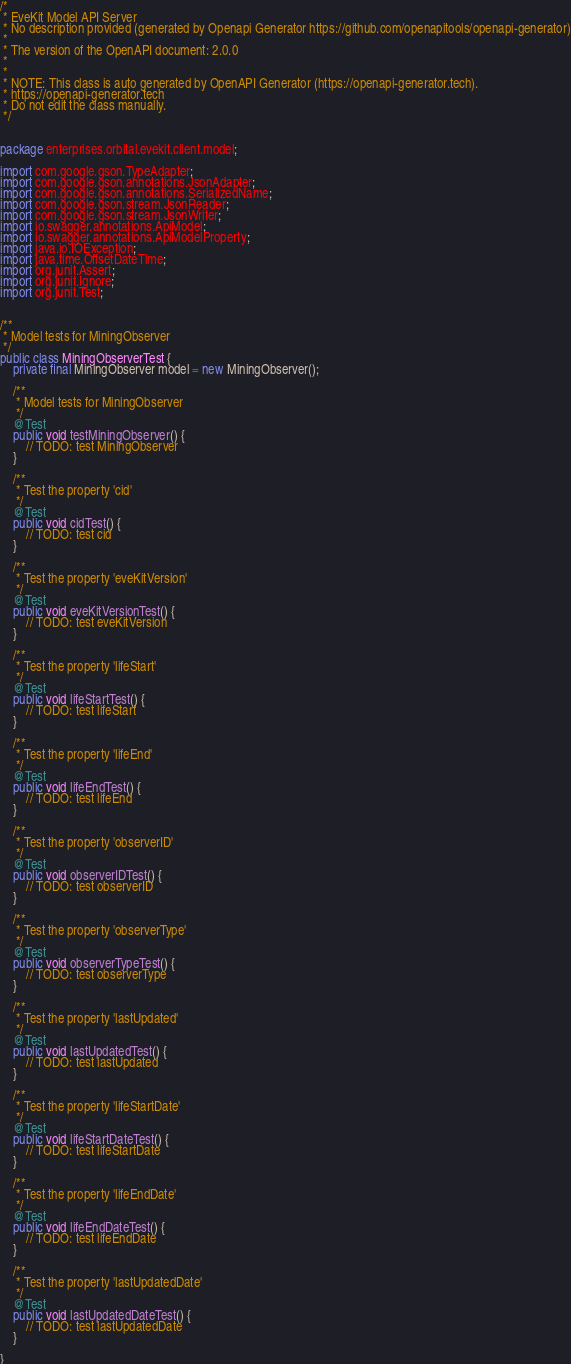<code> <loc_0><loc_0><loc_500><loc_500><_Java_>/*
 * EveKit Model API Server
 * No description provided (generated by Openapi Generator https://github.com/openapitools/openapi-generator)
 *
 * The version of the OpenAPI document: 2.0.0
 * 
 *
 * NOTE: This class is auto generated by OpenAPI Generator (https://openapi-generator.tech).
 * https://openapi-generator.tech
 * Do not edit the class manually.
 */


package enterprises.orbital.evekit.client.model;

import com.google.gson.TypeAdapter;
import com.google.gson.annotations.JsonAdapter;
import com.google.gson.annotations.SerializedName;
import com.google.gson.stream.JsonReader;
import com.google.gson.stream.JsonWriter;
import io.swagger.annotations.ApiModel;
import io.swagger.annotations.ApiModelProperty;
import java.io.IOException;
import java.time.OffsetDateTime;
import org.junit.Assert;
import org.junit.Ignore;
import org.junit.Test;


/**
 * Model tests for MiningObserver
 */
public class MiningObserverTest {
    private final MiningObserver model = new MiningObserver();

    /**
     * Model tests for MiningObserver
     */
    @Test
    public void testMiningObserver() {
        // TODO: test MiningObserver
    }

    /**
     * Test the property 'cid'
     */
    @Test
    public void cidTest() {
        // TODO: test cid
    }

    /**
     * Test the property 'eveKitVersion'
     */
    @Test
    public void eveKitVersionTest() {
        // TODO: test eveKitVersion
    }

    /**
     * Test the property 'lifeStart'
     */
    @Test
    public void lifeStartTest() {
        // TODO: test lifeStart
    }

    /**
     * Test the property 'lifeEnd'
     */
    @Test
    public void lifeEndTest() {
        // TODO: test lifeEnd
    }

    /**
     * Test the property 'observerID'
     */
    @Test
    public void observerIDTest() {
        // TODO: test observerID
    }

    /**
     * Test the property 'observerType'
     */
    @Test
    public void observerTypeTest() {
        // TODO: test observerType
    }

    /**
     * Test the property 'lastUpdated'
     */
    @Test
    public void lastUpdatedTest() {
        // TODO: test lastUpdated
    }

    /**
     * Test the property 'lifeStartDate'
     */
    @Test
    public void lifeStartDateTest() {
        // TODO: test lifeStartDate
    }

    /**
     * Test the property 'lifeEndDate'
     */
    @Test
    public void lifeEndDateTest() {
        // TODO: test lifeEndDate
    }

    /**
     * Test the property 'lastUpdatedDate'
     */
    @Test
    public void lastUpdatedDateTest() {
        // TODO: test lastUpdatedDate
    }

}
</code> 